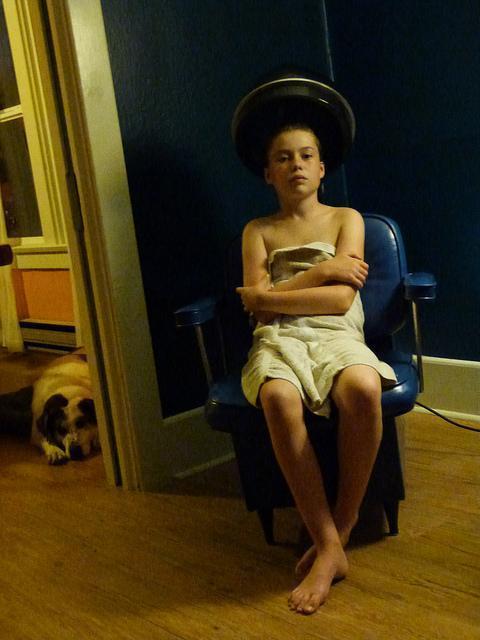How many train cars can be seen?
Give a very brief answer. 0. 